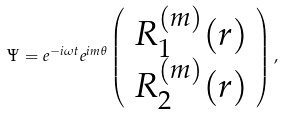<formula> <loc_0><loc_0><loc_500><loc_500>\Psi = e ^ { - i \omega t } e ^ { i m \theta } \left ( \begin{array} { c } R _ { 1 } ^ { ( m ) } ( r ) \\ R _ { 2 } ^ { ( m ) } ( r ) \end{array} \right ) ,</formula> 